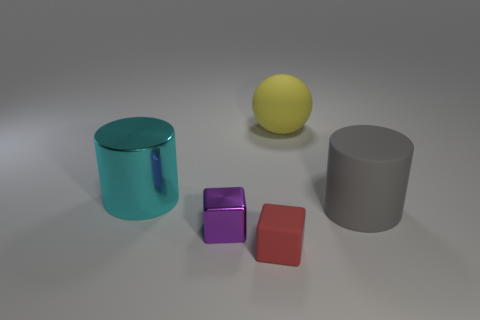Add 5 cyan shiny cylinders. How many objects exist? 10 Subtract all cylinders. How many objects are left? 3 Subtract all tiny red metallic objects. Subtract all small objects. How many objects are left? 3 Add 4 spheres. How many spheres are left? 5 Add 2 large yellow metallic blocks. How many large yellow metallic blocks exist? 2 Subtract 0 green balls. How many objects are left? 5 